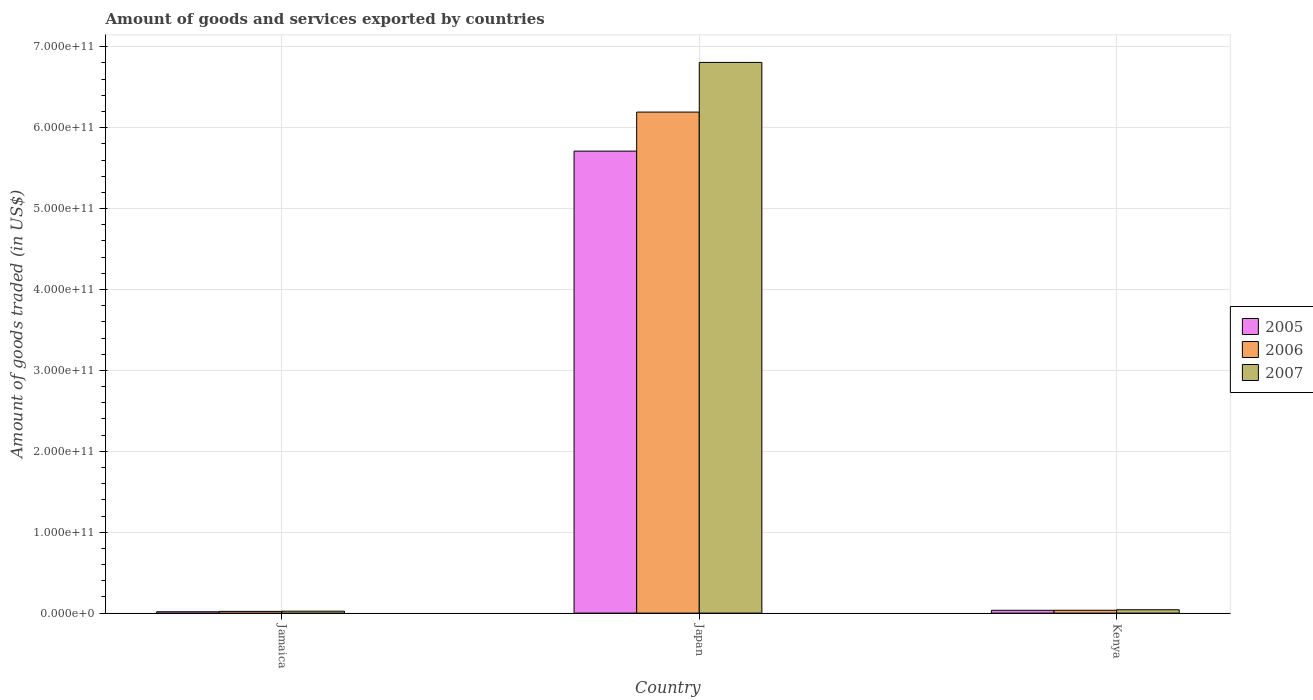Are the number of bars per tick equal to the number of legend labels?
Your answer should be compact. Yes. How many bars are there on the 1st tick from the left?
Your answer should be very brief. 3. What is the label of the 3rd group of bars from the left?
Provide a succinct answer. Kenya. What is the total amount of goods and services exported in 2005 in Japan?
Your answer should be compact. 5.71e+11. Across all countries, what is the maximum total amount of goods and services exported in 2007?
Provide a succinct answer. 6.81e+11. Across all countries, what is the minimum total amount of goods and services exported in 2006?
Your answer should be very brief. 2.13e+09. In which country was the total amount of goods and services exported in 2007 maximum?
Offer a very short reply. Japan. In which country was the total amount of goods and services exported in 2006 minimum?
Make the answer very short. Jamaica. What is the total total amount of goods and services exported in 2007 in the graph?
Your answer should be compact. 6.87e+11. What is the difference between the total amount of goods and services exported in 2005 in Japan and that in Kenya?
Your answer should be very brief. 5.68e+11. What is the difference between the total amount of goods and services exported in 2006 in Jamaica and the total amount of goods and services exported in 2005 in Japan?
Offer a very short reply. -5.69e+11. What is the average total amount of goods and services exported in 2007 per country?
Your response must be concise. 2.29e+11. What is the difference between the total amount of goods and services exported of/in 2006 and total amount of goods and services exported of/in 2005 in Japan?
Your answer should be very brief. 4.82e+1. What is the ratio of the total amount of goods and services exported in 2005 in Jamaica to that in Japan?
Your response must be concise. 0. Is the total amount of goods and services exported in 2006 in Jamaica less than that in Kenya?
Make the answer very short. Yes. What is the difference between the highest and the second highest total amount of goods and services exported in 2005?
Your response must be concise. 5.69e+11. What is the difference between the highest and the lowest total amount of goods and services exported in 2007?
Provide a short and direct response. 6.78e+11. Is the sum of the total amount of goods and services exported in 2006 in Jamaica and Kenya greater than the maximum total amount of goods and services exported in 2007 across all countries?
Provide a short and direct response. No. What does the 3rd bar from the left in Jamaica represents?
Keep it short and to the point. 2007. What does the 1st bar from the right in Jamaica represents?
Keep it short and to the point. 2007. Is it the case that in every country, the sum of the total amount of goods and services exported in 2005 and total amount of goods and services exported in 2006 is greater than the total amount of goods and services exported in 2007?
Provide a succinct answer. Yes. How many bars are there?
Make the answer very short. 9. What is the difference between two consecutive major ticks on the Y-axis?
Provide a succinct answer. 1.00e+11. Are the values on the major ticks of Y-axis written in scientific E-notation?
Make the answer very short. Yes. Does the graph contain grids?
Your response must be concise. Yes. What is the title of the graph?
Give a very brief answer. Amount of goods and services exported by countries. Does "1978" appear as one of the legend labels in the graph?
Offer a terse response. No. What is the label or title of the Y-axis?
Your response must be concise. Amount of goods traded (in US$). What is the Amount of goods traded (in US$) in 2005 in Jamaica?
Keep it short and to the point. 1.66e+09. What is the Amount of goods traded (in US$) of 2006 in Jamaica?
Make the answer very short. 2.13e+09. What is the Amount of goods traded (in US$) of 2007 in Jamaica?
Keep it short and to the point. 2.36e+09. What is the Amount of goods traded (in US$) in 2005 in Japan?
Keep it short and to the point. 5.71e+11. What is the Amount of goods traded (in US$) in 2006 in Japan?
Keep it short and to the point. 6.19e+11. What is the Amount of goods traded (in US$) in 2007 in Japan?
Your answer should be very brief. 6.81e+11. What is the Amount of goods traded (in US$) in 2005 in Kenya?
Your answer should be compact. 3.46e+09. What is the Amount of goods traded (in US$) of 2006 in Kenya?
Your response must be concise. 3.51e+09. What is the Amount of goods traded (in US$) of 2007 in Kenya?
Ensure brevity in your answer.  4.12e+09. Across all countries, what is the maximum Amount of goods traded (in US$) of 2005?
Ensure brevity in your answer.  5.71e+11. Across all countries, what is the maximum Amount of goods traded (in US$) of 2006?
Make the answer very short. 6.19e+11. Across all countries, what is the maximum Amount of goods traded (in US$) in 2007?
Make the answer very short. 6.81e+11. Across all countries, what is the minimum Amount of goods traded (in US$) in 2005?
Your answer should be compact. 1.66e+09. Across all countries, what is the minimum Amount of goods traded (in US$) of 2006?
Provide a short and direct response. 2.13e+09. Across all countries, what is the minimum Amount of goods traded (in US$) of 2007?
Your response must be concise. 2.36e+09. What is the total Amount of goods traded (in US$) of 2005 in the graph?
Provide a short and direct response. 5.76e+11. What is the total Amount of goods traded (in US$) of 2006 in the graph?
Offer a very short reply. 6.25e+11. What is the total Amount of goods traded (in US$) in 2007 in the graph?
Your response must be concise. 6.87e+11. What is the difference between the Amount of goods traded (in US$) of 2005 in Jamaica and that in Japan?
Offer a terse response. -5.69e+11. What is the difference between the Amount of goods traded (in US$) of 2006 in Jamaica and that in Japan?
Provide a short and direct response. -6.17e+11. What is the difference between the Amount of goods traded (in US$) in 2007 in Jamaica and that in Japan?
Your answer should be very brief. -6.78e+11. What is the difference between the Amount of goods traded (in US$) in 2005 in Jamaica and that in Kenya?
Keep it short and to the point. -1.80e+09. What is the difference between the Amount of goods traded (in US$) of 2006 in Jamaica and that in Kenya?
Offer a terse response. -1.38e+09. What is the difference between the Amount of goods traded (in US$) of 2007 in Jamaica and that in Kenya?
Your answer should be very brief. -1.76e+09. What is the difference between the Amount of goods traded (in US$) of 2005 in Japan and that in Kenya?
Your answer should be compact. 5.68e+11. What is the difference between the Amount of goods traded (in US$) of 2006 in Japan and that in Kenya?
Make the answer very short. 6.16e+11. What is the difference between the Amount of goods traded (in US$) in 2007 in Japan and that in Kenya?
Your answer should be very brief. 6.76e+11. What is the difference between the Amount of goods traded (in US$) in 2005 in Jamaica and the Amount of goods traded (in US$) in 2006 in Japan?
Make the answer very short. -6.18e+11. What is the difference between the Amount of goods traded (in US$) in 2005 in Jamaica and the Amount of goods traded (in US$) in 2007 in Japan?
Give a very brief answer. -6.79e+11. What is the difference between the Amount of goods traded (in US$) in 2006 in Jamaica and the Amount of goods traded (in US$) in 2007 in Japan?
Your response must be concise. -6.78e+11. What is the difference between the Amount of goods traded (in US$) in 2005 in Jamaica and the Amount of goods traded (in US$) in 2006 in Kenya?
Provide a succinct answer. -1.84e+09. What is the difference between the Amount of goods traded (in US$) of 2005 in Jamaica and the Amount of goods traded (in US$) of 2007 in Kenya?
Offer a very short reply. -2.46e+09. What is the difference between the Amount of goods traded (in US$) of 2006 in Jamaica and the Amount of goods traded (in US$) of 2007 in Kenya?
Offer a terse response. -1.99e+09. What is the difference between the Amount of goods traded (in US$) in 2005 in Japan and the Amount of goods traded (in US$) in 2006 in Kenya?
Your answer should be compact. 5.67e+11. What is the difference between the Amount of goods traded (in US$) in 2005 in Japan and the Amount of goods traded (in US$) in 2007 in Kenya?
Give a very brief answer. 5.67e+11. What is the difference between the Amount of goods traded (in US$) of 2006 in Japan and the Amount of goods traded (in US$) of 2007 in Kenya?
Your answer should be compact. 6.15e+11. What is the average Amount of goods traded (in US$) of 2005 per country?
Your answer should be very brief. 1.92e+11. What is the average Amount of goods traded (in US$) in 2006 per country?
Your response must be concise. 2.08e+11. What is the average Amount of goods traded (in US$) of 2007 per country?
Make the answer very short. 2.29e+11. What is the difference between the Amount of goods traded (in US$) of 2005 and Amount of goods traded (in US$) of 2006 in Jamaica?
Keep it short and to the point. -4.69e+08. What is the difference between the Amount of goods traded (in US$) of 2005 and Amount of goods traded (in US$) of 2007 in Jamaica?
Ensure brevity in your answer.  -6.98e+08. What is the difference between the Amount of goods traded (in US$) of 2006 and Amount of goods traded (in US$) of 2007 in Jamaica?
Your answer should be compact. -2.29e+08. What is the difference between the Amount of goods traded (in US$) in 2005 and Amount of goods traded (in US$) in 2006 in Japan?
Offer a terse response. -4.82e+1. What is the difference between the Amount of goods traded (in US$) of 2005 and Amount of goods traded (in US$) of 2007 in Japan?
Keep it short and to the point. -1.10e+11. What is the difference between the Amount of goods traded (in US$) of 2006 and Amount of goods traded (in US$) of 2007 in Japan?
Provide a short and direct response. -6.14e+1. What is the difference between the Amount of goods traded (in US$) in 2005 and Amount of goods traded (in US$) in 2006 in Kenya?
Provide a succinct answer. -4.95e+07. What is the difference between the Amount of goods traded (in US$) of 2005 and Amount of goods traded (in US$) of 2007 in Kenya?
Make the answer very short. -6.64e+08. What is the difference between the Amount of goods traded (in US$) of 2006 and Amount of goods traded (in US$) of 2007 in Kenya?
Provide a succinct answer. -6.14e+08. What is the ratio of the Amount of goods traded (in US$) of 2005 in Jamaica to that in Japan?
Make the answer very short. 0. What is the ratio of the Amount of goods traded (in US$) in 2006 in Jamaica to that in Japan?
Your answer should be compact. 0. What is the ratio of the Amount of goods traded (in US$) in 2007 in Jamaica to that in Japan?
Keep it short and to the point. 0. What is the ratio of the Amount of goods traded (in US$) of 2005 in Jamaica to that in Kenya?
Your answer should be very brief. 0.48. What is the ratio of the Amount of goods traded (in US$) in 2006 in Jamaica to that in Kenya?
Your answer should be compact. 0.61. What is the ratio of the Amount of goods traded (in US$) in 2007 in Jamaica to that in Kenya?
Offer a terse response. 0.57. What is the ratio of the Amount of goods traded (in US$) of 2005 in Japan to that in Kenya?
Offer a terse response. 165.05. What is the ratio of the Amount of goods traded (in US$) of 2006 in Japan to that in Kenya?
Your answer should be very brief. 176.47. What is the ratio of the Amount of goods traded (in US$) in 2007 in Japan to that in Kenya?
Provide a succinct answer. 165.07. What is the difference between the highest and the second highest Amount of goods traded (in US$) in 2005?
Provide a short and direct response. 5.68e+11. What is the difference between the highest and the second highest Amount of goods traded (in US$) in 2006?
Your answer should be very brief. 6.16e+11. What is the difference between the highest and the second highest Amount of goods traded (in US$) in 2007?
Give a very brief answer. 6.76e+11. What is the difference between the highest and the lowest Amount of goods traded (in US$) of 2005?
Make the answer very short. 5.69e+11. What is the difference between the highest and the lowest Amount of goods traded (in US$) in 2006?
Your response must be concise. 6.17e+11. What is the difference between the highest and the lowest Amount of goods traded (in US$) of 2007?
Your answer should be compact. 6.78e+11. 